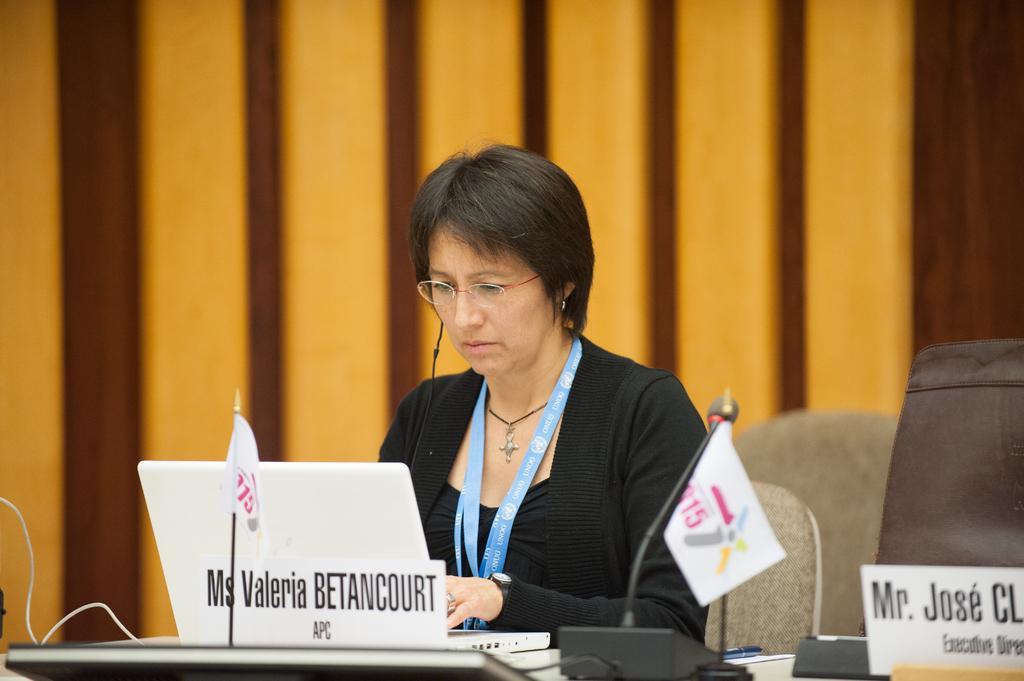In one or two sentences, can you explain what this image depicts? There is a woman sitting and wore tag and we can see name boards, microphone, laptop,flags and some objects on table. Background we can see wall. 